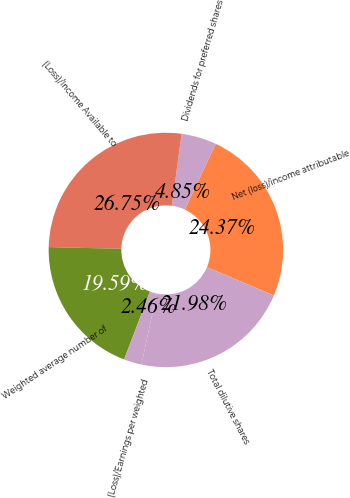Convert chart. <chart><loc_0><loc_0><loc_500><loc_500><pie_chart><fcel>Net (loss)/income attributable<fcel>Dividends for preferred shares<fcel>(Loss)/Income Available to<fcel>Weighted average number of<fcel>(Loss)/Earnings per weighted<fcel>Total dilutive shares<nl><fcel>24.37%<fcel>4.85%<fcel>26.75%<fcel>19.59%<fcel>2.46%<fcel>21.98%<nl></chart> 